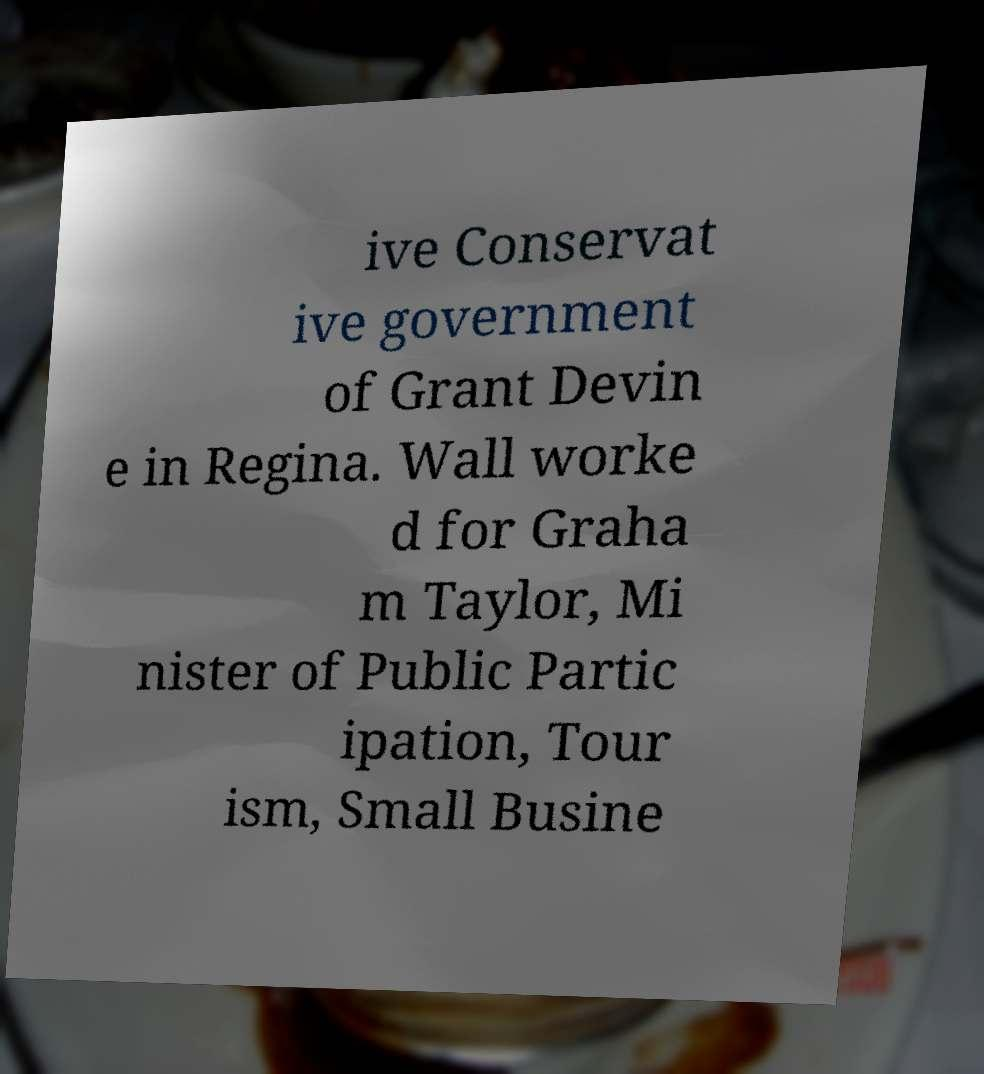There's text embedded in this image that I need extracted. Can you transcribe it verbatim? ive Conservat ive government of Grant Devin e in Regina. Wall worke d for Graha m Taylor, Mi nister of Public Partic ipation, Tour ism, Small Busine 